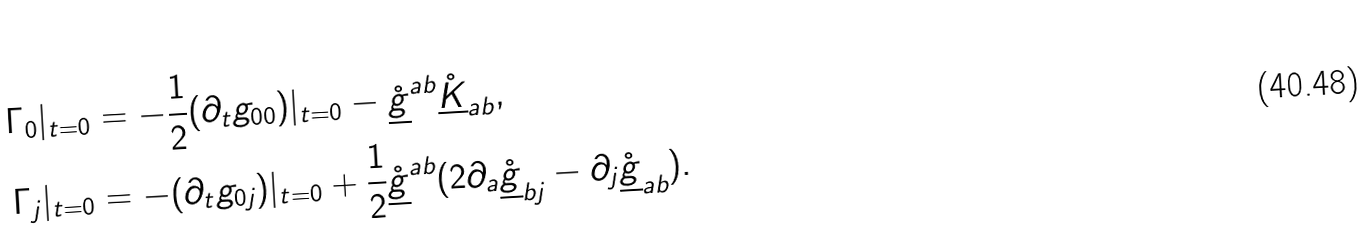Convert formula to latex. <formula><loc_0><loc_0><loc_500><loc_500>\Gamma _ { 0 } | _ { t = 0 } & = - \frac { 1 } { 2 } ( \partial _ { t } g _ { 0 0 } ) | _ { t = 0 } - \mathring { \underline { g } } ^ { a b } \mathring { \underline { K } } _ { a b } , \\ \Gamma _ { j } | _ { t = 0 } & = - ( \partial _ { t } g _ { 0 j } ) | _ { t = 0 } + \frac { 1 } { 2 } \mathring { \underline { g } } ^ { a b } ( 2 \partial _ { a } \mathring { \underline { g } } _ { b j } - \partial _ { j } \mathring { \underline { g } } _ { a b } ) .</formula> 